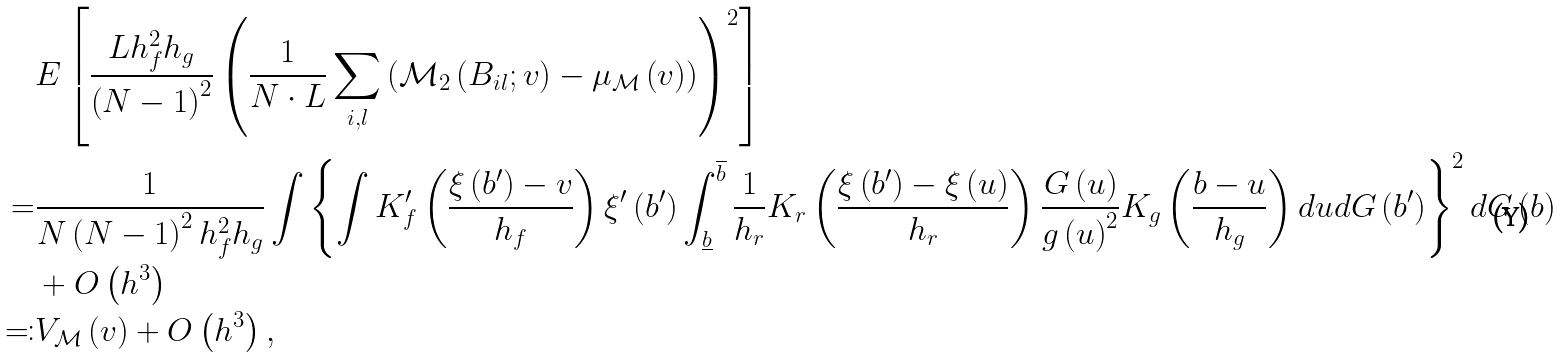<formula> <loc_0><loc_0><loc_500><loc_500>& E \left [ \frac { L h _ { f } ^ { 2 } h _ { g } } { \left ( N - 1 \right ) ^ { 2 } } \left ( \frac { 1 } { N \cdot L } \sum _ { i , l } \left ( \mathcal { M } _ { 2 } \left ( B _ { i l } ; v \right ) - \mu _ { \mathcal { M } } \left ( v \right ) \right ) \right ) ^ { 2 } \right ] \\ = & \frac { 1 } { N \left ( N - 1 \right ) ^ { 2 } h _ { f } ^ { 2 } h _ { g } } \int \left \{ \int K _ { f } ^ { \prime } \left ( \frac { \xi \left ( b ^ { \prime } \right ) - v } { h _ { f } } \right ) \xi ^ { \prime } \left ( b ^ { \prime } \right ) \int _ { \underline { b } } ^ { \overline { b } } \frac { 1 } { h _ { r } } K _ { r } \left ( \frac { \xi \left ( b ^ { \prime } \right ) - \xi \left ( u \right ) } { h _ { r } } \right ) \frac { G \left ( u \right ) } { g \left ( u \right ) ^ { 2 } } K _ { g } \left ( \frac { b - u } { h _ { g } } \right ) d u d G \left ( b ^ { \prime } \right ) \right \} ^ { 2 } d G \left ( b \right ) \\ & + O \left ( h ^ { 3 } \right ) \\ \eqqcolon & V _ { \mathcal { M } } \left ( v \right ) + O \left ( h ^ { 3 } \right ) ,</formula> 